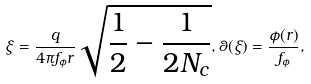<formula> <loc_0><loc_0><loc_500><loc_500>\xi = \frac { q } { 4 \pi f _ { \phi } r } \sqrt { \frac { 1 } { 2 } - \frac { 1 } { 2 N _ { c } } } , \theta ( \xi ) = \frac { \phi ( r ) } { f _ { \phi } } ,</formula> 